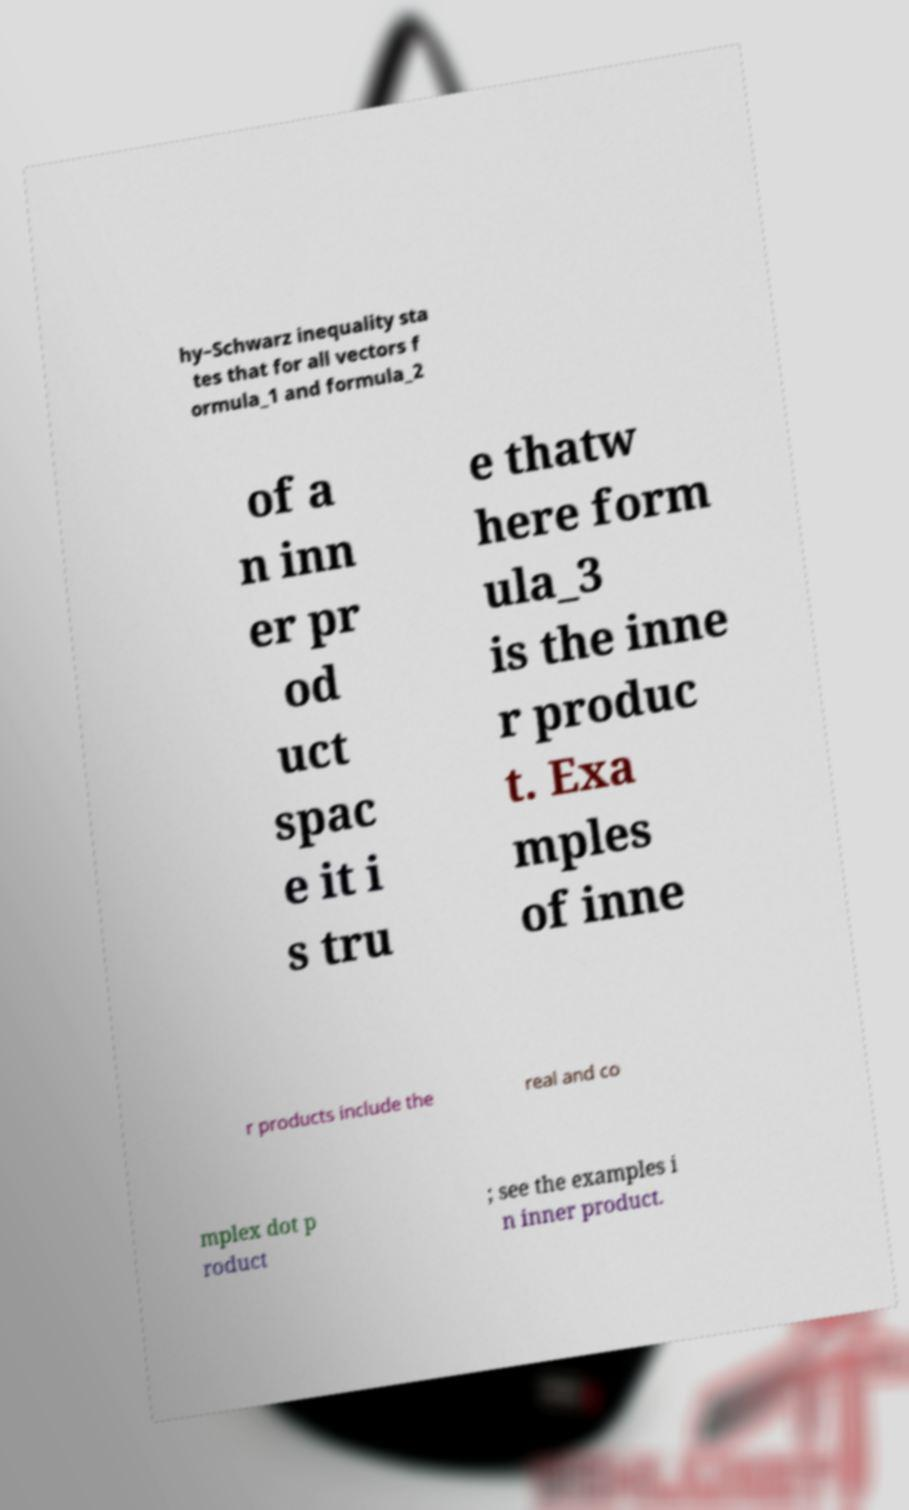For documentation purposes, I need the text within this image transcribed. Could you provide that? hy–Schwarz inequality sta tes that for all vectors f ormula_1 and formula_2 of a n inn er pr od uct spac e it i s tru e thatw here form ula_3 is the inne r produc t. Exa mples of inne r products include the real and co mplex dot p roduct ; see the examples i n inner product. 